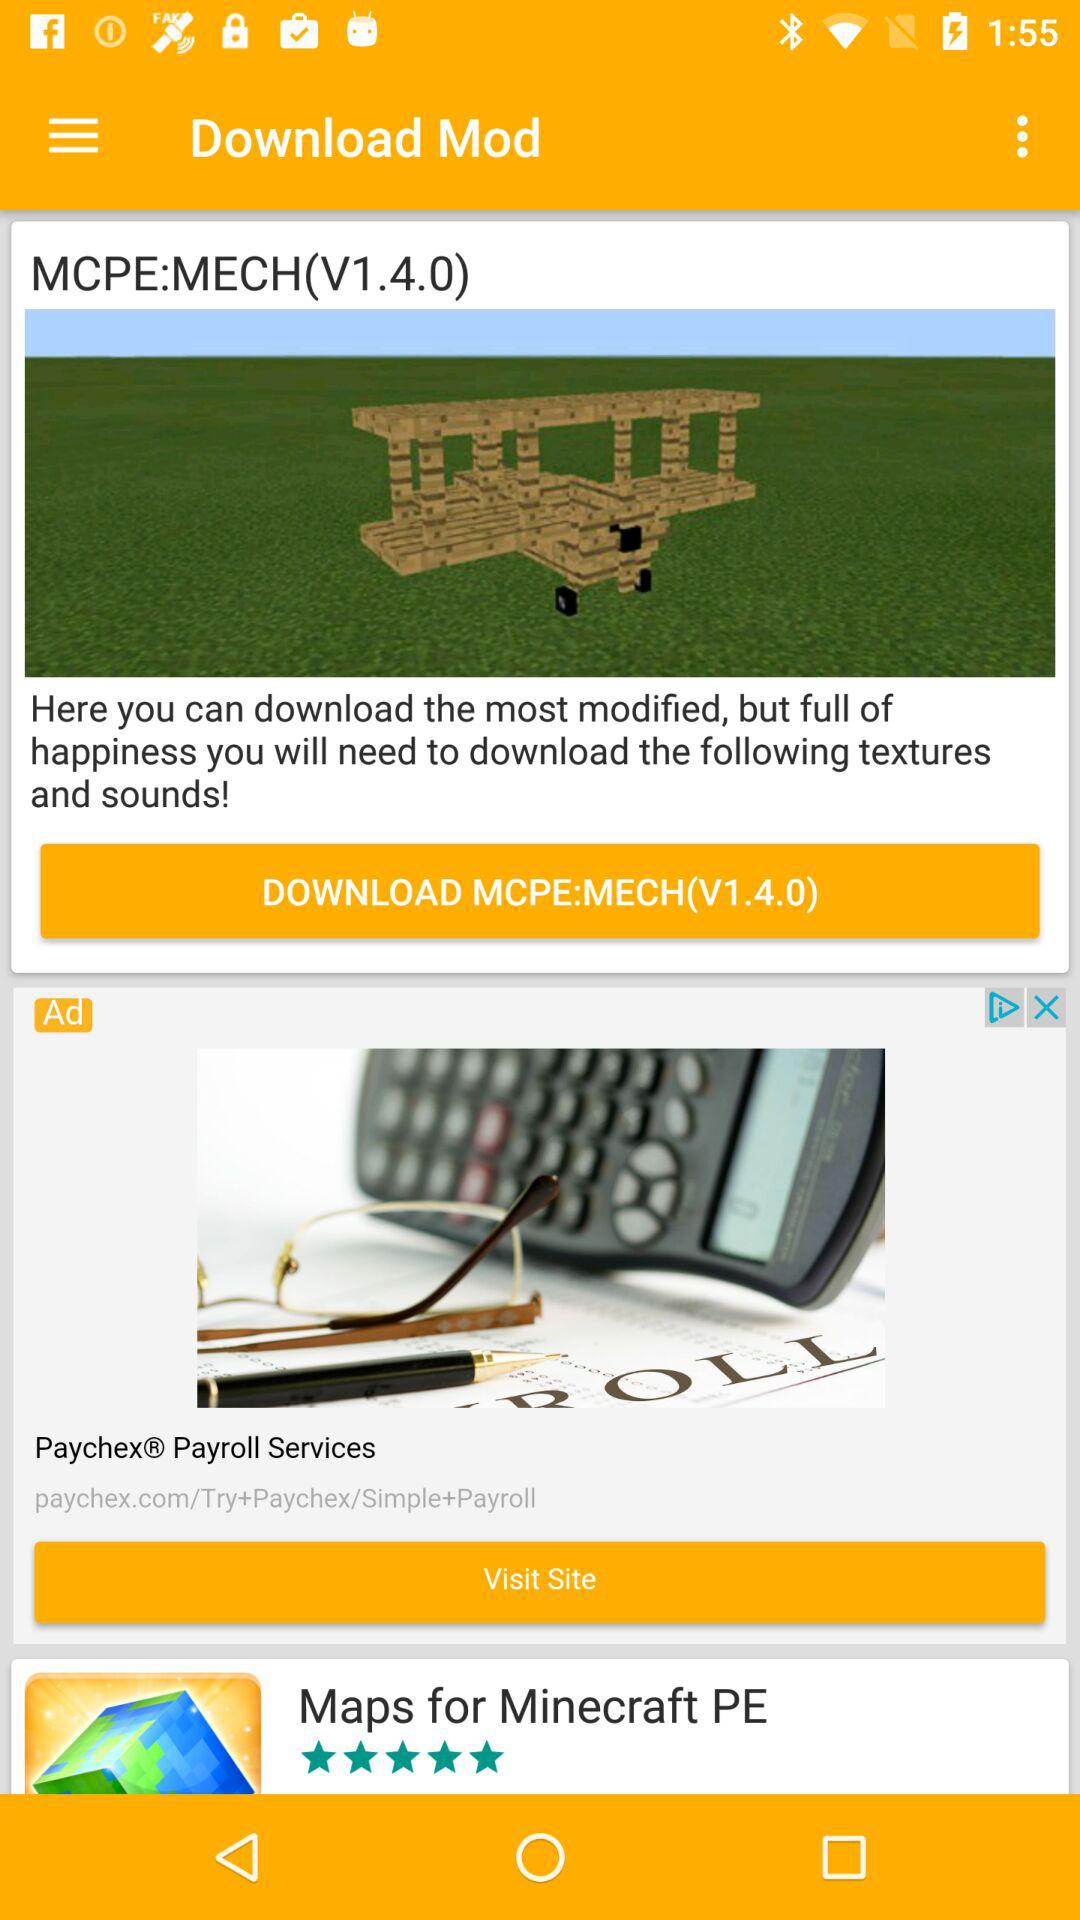What is the rating of "Maps for Minecraft PE"? The rating is 5 stars. 